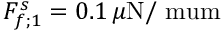<formula> <loc_0><loc_0><loc_500><loc_500>F _ { f ; 1 } ^ { s } = 0 . 1 \, \mu N / \ m u m</formula> 